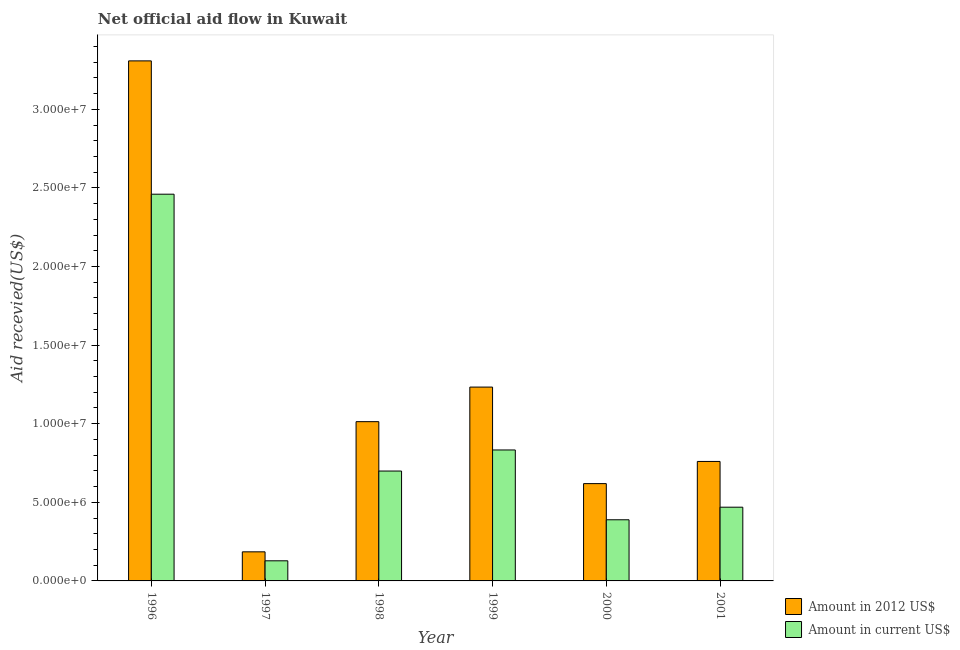How many different coloured bars are there?
Offer a very short reply. 2. Are the number of bars on each tick of the X-axis equal?
Give a very brief answer. Yes. How many bars are there on the 4th tick from the right?
Your answer should be compact. 2. What is the amount of aid received(expressed in 2012 us$) in 2000?
Your answer should be very brief. 6.19e+06. Across all years, what is the maximum amount of aid received(expressed in 2012 us$)?
Offer a terse response. 3.31e+07. Across all years, what is the minimum amount of aid received(expressed in 2012 us$)?
Offer a terse response. 1.85e+06. What is the total amount of aid received(expressed in us$) in the graph?
Offer a very short reply. 4.98e+07. What is the difference between the amount of aid received(expressed in us$) in 2000 and that in 2001?
Your response must be concise. -8.00e+05. What is the difference between the amount of aid received(expressed in 2012 us$) in 2001 and the amount of aid received(expressed in us$) in 1998?
Make the answer very short. -2.53e+06. What is the average amount of aid received(expressed in 2012 us$) per year?
Your answer should be compact. 1.19e+07. In how many years, is the amount of aid received(expressed in 2012 us$) greater than 23000000 US$?
Provide a succinct answer. 1. What is the ratio of the amount of aid received(expressed in 2012 us$) in 1998 to that in 2001?
Keep it short and to the point. 1.33. What is the difference between the highest and the second highest amount of aid received(expressed in us$)?
Ensure brevity in your answer.  1.63e+07. What is the difference between the highest and the lowest amount of aid received(expressed in us$)?
Ensure brevity in your answer.  2.33e+07. Is the sum of the amount of aid received(expressed in us$) in 1997 and 2001 greater than the maximum amount of aid received(expressed in 2012 us$) across all years?
Your answer should be very brief. No. What does the 2nd bar from the left in 1997 represents?
Make the answer very short. Amount in current US$. What does the 2nd bar from the right in 1999 represents?
Your response must be concise. Amount in 2012 US$. How many years are there in the graph?
Provide a short and direct response. 6. What is the difference between two consecutive major ticks on the Y-axis?
Give a very brief answer. 5.00e+06. Does the graph contain any zero values?
Make the answer very short. No. What is the title of the graph?
Keep it short and to the point. Net official aid flow in Kuwait. Does "Rural Population" appear as one of the legend labels in the graph?
Provide a short and direct response. No. What is the label or title of the Y-axis?
Your response must be concise. Aid recevied(US$). What is the Aid recevied(US$) in Amount in 2012 US$ in 1996?
Your response must be concise. 3.31e+07. What is the Aid recevied(US$) in Amount in current US$ in 1996?
Give a very brief answer. 2.46e+07. What is the Aid recevied(US$) in Amount in 2012 US$ in 1997?
Ensure brevity in your answer.  1.85e+06. What is the Aid recevied(US$) in Amount in current US$ in 1997?
Your response must be concise. 1.28e+06. What is the Aid recevied(US$) in Amount in 2012 US$ in 1998?
Give a very brief answer. 1.01e+07. What is the Aid recevied(US$) in Amount in current US$ in 1998?
Offer a terse response. 6.99e+06. What is the Aid recevied(US$) of Amount in 2012 US$ in 1999?
Your answer should be compact. 1.23e+07. What is the Aid recevied(US$) of Amount in current US$ in 1999?
Offer a very short reply. 8.33e+06. What is the Aid recevied(US$) of Amount in 2012 US$ in 2000?
Your answer should be compact. 6.19e+06. What is the Aid recevied(US$) of Amount in current US$ in 2000?
Provide a short and direct response. 3.89e+06. What is the Aid recevied(US$) in Amount in 2012 US$ in 2001?
Keep it short and to the point. 7.60e+06. What is the Aid recevied(US$) in Amount in current US$ in 2001?
Your response must be concise. 4.69e+06. Across all years, what is the maximum Aid recevied(US$) of Amount in 2012 US$?
Provide a succinct answer. 3.31e+07. Across all years, what is the maximum Aid recevied(US$) in Amount in current US$?
Offer a terse response. 2.46e+07. Across all years, what is the minimum Aid recevied(US$) in Amount in 2012 US$?
Your response must be concise. 1.85e+06. Across all years, what is the minimum Aid recevied(US$) in Amount in current US$?
Keep it short and to the point. 1.28e+06. What is the total Aid recevied(US$) in Amount in 2012 US$ in the graph?
Ensure brevity in your answer.  7.12e+07. What is the total Aid recevied(US$) of Amount in current US$ in the graph?
Give a very brief answer. 4.98e+07. What is the difference between the Aid recevied(US$) of Amount in 2012 US$ in 1996 and that in 1997?
Offer a terse response. 3.12e+07. What is the difference between the Aid recevied(US$) in Amount in current US$ in 1996 and that in 1997?
Give a very brief answer. 2.33e+07. What is the difference between the Aid recevied(US$) of Amount in 2012 US$ in 1996 and that in 1998?
Your response must be concise. 2.30e+07. What is the difference between the Aid recevied(US$) in Amount in current US$ in 1996 and that in 1998?
Provide a succinct answer. 1.76e+07. What is the difference between the Aid recevied(US$) of Amount in 2012 US$ in 1996 and that in 1999?
Your answer should be compact. 2.08e+07. What is the difference between the Aid recevied(US$) of Amount in current US$ in 1996 and that in 1999?
Give a very brief answer. 1.63e+07. What is the difference between the Aid recevied(US$) of Amount in 2012 US$ in 1996 and that in 2000?
Keep it short and to the point. 2.69e+07. What is the difference between the Aid recevied(US$) of Amount in current US$ in 1996 and that in 2000?
Your answer should be very brief. 2.07e+07. What is the difference between the Aid recevied(US$) in Amount in 2012 US$ in 1996 and that in 2001?
Your answer should be compact. 2.55e+07. What is the difference between the Aid recevied(US$) in Amount in current US$ in 1996 and that in 2001?
Keep it short and to the point. 1.99e+07. What is the difference between the Aid recevied(US$) of Amount in 2012 US$ in 1997 and that in 1998?
Keep it short and to the point. -8.28e+06. What is the difference between the Aid recevied(US$) of Amount in current US$ in 1997 and that in 1998?
Give a very brief answer. -5.71e+06. What is the difference between the Aid recevied(US$) of Amount in 2012 US$ in 1997 and that in 1999?
Your answer should be compact. -1.05e+07. What is the difference between the Aid recevied(US$) of Amount in current US$ in 1997 and that in 1999?
Offer a very short reply. -7.05e+06. What is the difference between the Aid recevied(US$) of Amount in 2012 US$ in 1997 and that in 2000?
Offer a terse response. -4.34e+06. What is the difference between the Aid recevied(US$) of Amount in current US$ in 1997 and that in 2000?
Your response must be concise. -2.61e+06. What is the difference between the Aid recevied(US$) of Amount in 2012 US$ in 1997 and that in 2001?
Provide a succinct answer. -5.75e+06. What is the difference between the Aid recevied(US$) in Amount in current US$ in 1997 and that in 2001?
Make the answer very short. -3.41e+06. What is the difference between the Aid recevied(US$) in Amount in 2012 US$ in 1998 and that in 1999?
Your response must be concise. -2.20e+06. What is the difference between the Aid recevied(US$) of Amount in current US$ in 1998 and that in 1999?
Make the answer very short. -1.34e+06. What is the difference between the Aid recevied(US$) of Amount in 2012 US$ in 1998 and that in 2000?
Your answer should be compact. 3.94e+06. What is the difference between the Aid recevied(US$) in Amount in current US$ in 1998 and that in 2000?
Make the answer very short. 3.10e+06. What is the difference between the Aid recevied(US$) in Amount in 2012 US$ in 1998 and that in 2001?
Make the answer very short. 2.53e+06. What is the difference between the Aid recevied(US$) of Amount in current US$ in 1998 and that in 2001?
Offer a very short reply. 2.30e+06. What is the difference between the Aid recevied(US$) of Amount in 2012 US$ in 1999 and that in 2000?
Offer a terse response. 6.14e+06. What is the difference between the Aid recevied(US$) in Amount in current US$ in 1999 and that in 2000?
Your response must be concise. 4.44e+06. What is the difference between the Aid recevied(US$) of Amount in 2012 US$ in 1999 and that in 2001?
Keep it short and to the point. 4.73e+06. What is the difference between the Aid recevied(US$) of Amount in current US$ in 1999 and that in 2001?
Keep it short and to the point. 3.64e+06. What is the difference between the Aid recevied(US$) of Amount in 2012 US$ in 2000 and that in 2001?
Your response must be concise. -1.41e+06. What is the difference between the Aid recevied(US$) of Amount in current US$ in 2000 and that in 2001?
Your response must be concise. -8.00e+05. What is the difference between the Aid recevied(US$) in Amount in 2012 US$ in 1996 and the Aid recevied(US$) in Amount in current US$ in 1997?
Your response must be concise. 3.18e+07. What is the difference between the Aid recevied(US$) in Amount in 2012 US$ in 1996 and the Aid recevied(US$) in Amount in current US$ in 1998?
Provide a short and direct response. 2.61e+07. What is the difference between the Aid recevied(US$) in Amount in 2012 US$ in 1996 and the Aid recevied(US$) in Amount in current US$ in 1999?
Your response must be concise. 2.48e+07. What is the difference between the Aid recevied(US$) in Amount in 2012 US$ in 1996 and the Aid recevied(US$) in Amount in current US$ in 2000?
Give a very brief answer. 2.92e+07. What is the difference between the Aid recevied(US$) of Amount in 2012 US$ in 1996 and the Aid recevied(US$) of Amount in current US$ in 2001?
Give a very brief answer. 2.84e+07. What is the difference between the Aid recevied(US$) in Amount in 2012 US$ in 1997 and the Aid recevied(US$) in Amount in current US$ in 1998?
Ensure brevity in your answer.  -5.14e+06. What is the difference between the Aid recevied(US$) in Amount in 2012 US$ in 1997 and the Aid recevied(US$) in Amount in current US$ in 1999?
Your answer should be compact. -6.48e+06. What is the difference between the Aid recevied(US$) of Amount in 2012 US$ in 1997 and the Aid recevied(US$) of Amount in current US$ in 2000?
Offer a very short reply. -2.04e+06. What is the difference between the Aid recevied(US$) in Amount in 2012 US$ in 1997 and the Aid recevied(US$) in Amount in current US$ in 2001?
Your response must be concise. -2.84e+06. What is the difference between the Aid recevied(US$) in Amount in 2012 US$ in 1998 and the Aid recevied(US$) in Amount in current US$ in 1999?
Your answer should be very brief. 1.80e+06. What is the difference between the Aid recevied(US$) of Amount in 2012 US$ in 1998 and the Aid recevied(US$) of Amount in current US$ in 2000?
Ensure brevity in your answer.  6.24e+06. What is the difference between the Aid recevied(US$) in Amount in 2012 US$ in 1998 and the Aid recevied(US$) in Amount in current US$ in 2001?
Ensure brevity in your answer.  5.44e+06. What is the difference between the Aid recevied(US$) in Amount in 2012 US$ in 1999 and the Aid recevied(US$) in Amount in current US$ in 2000?
Provide a short and direct response. 8.44e+06. What is the difference between the Aid recevied(US$) in Amount in 2012 US$ in 1999 and the Aid recevied(US$) in Amount in current US$ in 2001?
Your answer should be compact. 7.64e+06. What is the difference between the Aid recevied(US$) in Amount in 2012 US$ in 2000 and the Aid recevied(US$) in Amount in current US$ in 2001?
Make the answer very short. 1.50e+06. What is the average Aid recevied(US$) in Amount in 2012 US$ per year?
Keep it short and to the point. 1.19e+07. What is the average Aid recevied(US$) of Amount in current US$ per year?
Provide a succinct answer. 8.30e+06. In the year 1996, what is the difference between the Aid recevied(US$) in Amount in 2012 US$ and Aid recevied(US$) in Amount in current US$?
Keep it short and to the point. 8.48e+06. In the year 1997, what is the difference between the Aid recevied(US$) of Amount in 2012 US$ and Aid recevied(US$) of Amount in current US$?
Provide a short and direct response. 5.70e+05. In the year 1998, what is the difference between the Aid recevied(US$) of Amount in 2012 US$ and Aid recevied(US$) of Amount in current US$?
Your response must be concise. 3.14e+06. In the year 2000, what is the difference between the Aid recevied(US$) in Amount in 2012 US$ and Aid recevied(US$) in Amount in current US$?
Your answer should be compact. 2.30e+06. In the year 2001, what is the difference between the Aid recevied(US$) in Amount in 2012 US$ and Aid recevied(US$) in Amount in current US$?
Ensure brevity in your answer.  2.91e+06. What is the ratio of the Aid recevied(US$) of Amount in 2012 US$ in 1996 to that in 1997?
Give a very brief answer. 17.88. What is the ratio of the Aid recevied(US$) in Amount in current US$ in 1996 to that in 1997?
Your answer should be compact. 19.22. What is the ratio of the Aid recevied(US$) of Amount in 2012 US$ in 1996 to that in 1998?
Your answer should be compact. 3.27. What is the ratio of the Aid recevied(US$) of Amount in current US$ in 1996 to that in 1998?
Give a very brief answer. 3.52. What is the ratio of the Aid recevied(US$) in Amount in 2012 US$ in 1996 to that in 1999?
Provide a short and direct response. 2.68. What is the ratio of the Aid recevied(US$) in Amount in current US$ in 1996 to that in 1999?
Make the answer very short. 2.95. What is the ratio of the Aid recevied(US$) in Amount in 2012 US$ in 1996 to that in 2000?
Offer a terse response. 5.34. What is the ratio of the Aid recevied(US$) in Amount in current US$ in 1996 to that in 2000?
Your answer should be very brief. 6.32. What is the ratio of the Aid recevied(US$) in Amount in 2012 US$ in 1996 to that in 2001?
Offer a terse response. 4.35. What is the ratio of the Aid recevied(US$) in Amount in current US$ in 1996 to that in 2001?
Provide a short and direct response. 5.25. What is the ratio of the Aid recevied(US$) in Amount in 2012 US$ in 1997 to that in 1998?
Offer a terse response. 0.18. What is the ratio of the Aid recevied(US$) in Amount in current US$ in 1997 to that in 1998?
Provide a succinct answer. 0.18. What is the ratio of the Aid recevied(US$) of Amount in 2012 US$ in 1997 to that in 1999?
Give a very brief answer. 0.15. What is the ratio of the Aid recevied(US$) of Amount in current US$ in 1997 to that in 1999?
Ensure brevity in your answer.  0.15. What is the ratio of the Aid recevied(US$) of Amount in 2012 US$ in 1997 to that in 2000?
Your response must be concise. 0.3. What is the ratio of the Aid recevied(US$) in Amount in current US$ in 1997 to that in 2000?
Your answer should be very brief. 0.33. What is the ratio of the Aid recevied(US$) of Amount in 2012 US$ in 1997 to that in 2001?
Your answer should be compact. 0.24. What is the ratio of the Aid recevied(US$) in Amount in current US$ in 1997 to that in 2001?
Provide a short and direct response. 0.27. What is the ratio of the Aid recevied(US$) of Amount in 2012 US$ in 1998 to that in 1999?
Provide a succinct answer. 0.82. What is the ratio of the Aid recevied(US$) of Amount in current US$ in 1998 to that in 1999?
Your answer should be compact. 0.84. What is the ratio of the Aid recevied(US$) of Amount in 2012 US$ in 1998 to that in 2000?
Your response must be concise. 1.64. What is the ratio of the Aid recevied(US$) of Amount in current US$ in 1998 to that in 2000?
Give a very brief answer. 1.8. What is the ratio of the Aid recevied(US$) in Amount in 2012 US$ in 1998 to that in 2001?
Keep it short and to the point. 1.33. What is the ratio of the Aid recevied(US$) of Amount in current US$ in 1998 to that in 2001?
Offer a very short reply. 1.49. What is the ratio of the Aid recevied(US$) of Amount in 2012 US$ in 1999 to that in 2000?
Your answer should be very brief. 1.99. What is the ratio of the Aid recevied(US$) of Amount in current US$ in 1999 to that in 2000?
Your answer should be compact. 2.14. What is the ratio of the Aid recevied(US$) of Amount in 2012 US$ in 1999 to that in 2001?
Keep it short and to the point. 1.62. What is the ratio of the Aid recevied(US$) in Amount in current US$ in 1999 to that in 2001?
Ensure brevity in your answer.  1.78. What is the ratio of the Aid recevied(US$) in Amount in 2012 US$ in 2000 to that in 2001?
Offer a very short reply. 0.81. What is the ratio of the Aid recevied(US$) in Amount in current US$ in 2000 to that in 2001?
Your response must be concise. 0.83. What is the difference between the highest and the second highest Aid recevied(US$) in Amount in 2012 US$?
Offer a terse response. 2.08e+07. What is the difference between the highest and the second highest Aid recevied(US$) of Amount in current US$?
Offer a terse response. 1.63e+07. What is the difference between the highest and the lowest Aid recevied(US$) of Amount in 2012 US$?
Your response must be concise. 3.12e+07. What is the difference between the highest and the lowest Aid recevied(US$) in Amount in current US$?
Your answer should be compact. 2.33e+07. 